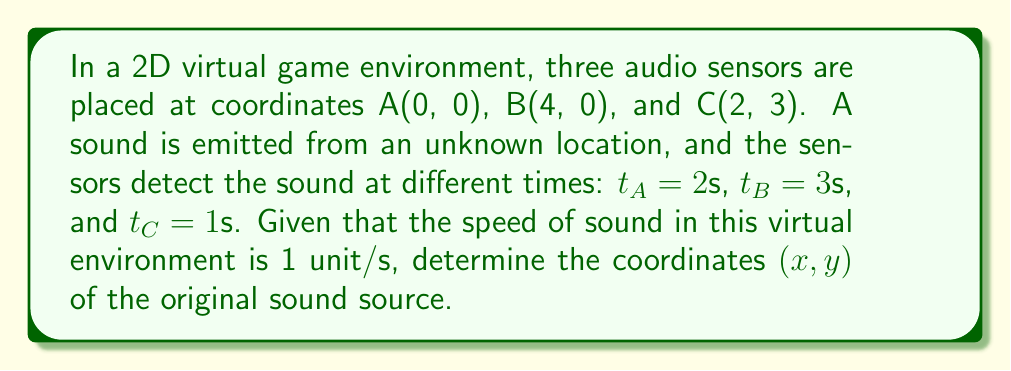Can you answer this question? Let's approach this step-by-step, using the principles of trilateration:

1) First, we need to set up equations for the distances from the sound source to each sensor. Let (x, y) be the coordinates of the sound source. The distance d is equal to the time t multiplied by the speed of sound (1 unit/s in this case).

   For sensor A: $d_A = t_A = \sqrt{x^2 + y^2} = 2$
   For sensor B: $d_B = t_B = \sqrt{(x-4)^2 + y^2} = 3$
   For sensor C: $d_C = t_C = \sqrt{(x-2)^2 + (y-3)^2} = 1$

2) Square both sides of each equation:

   $x^2 + y^2 = 4$
   $(x-4)^2 + y^2 = 9$
   $(x-2)^2 + (y-3)^2 = 1$

3) Expand the squared terms:

   $x^2 + y^2 = 4$
   $x^2 - 8x + 16 + y^2 = 9$
   $x^2 - 4x + 4 + y^2 - 6y + 9 = 1$

4) Subtract the first equation from the second:

   $-8x + 16 = 5$
   $x = \frac{11}{8} = 1.375$

5) Substitute this x value into the first equation:

   $(1.375)^2 + y^2 = 4$
   $y^2 = 4 - 1.890625 = 2.109375$
   $y = \sqrt{2.109375} \approx 1.453$

6) Verify with the third equation:

   $(1.375 - 2)^2 + (1.453 - 3)^2 \approx 1$

The result checks out within rounding error.
Answer: $(1.375, 1.453)$ 